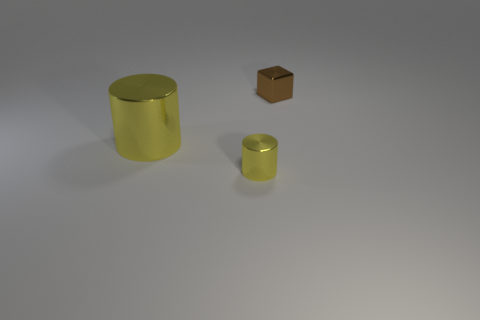Describe the lighting and mood of the image, please. The image exudes a calm and minimalist atmosphere. It's illuminated by a soft, diffuse light source that casts gentle shadows, enhancing the three-dimensional form of the objects without creating harsh contrasts. The neutral background and the sparse arrangement of the items suggest a focus on simplicity and form. This sort of lighting and composition might be used in a product showcase or an art installation to draw the viewer's attention to the qualities of the objects themselves. 